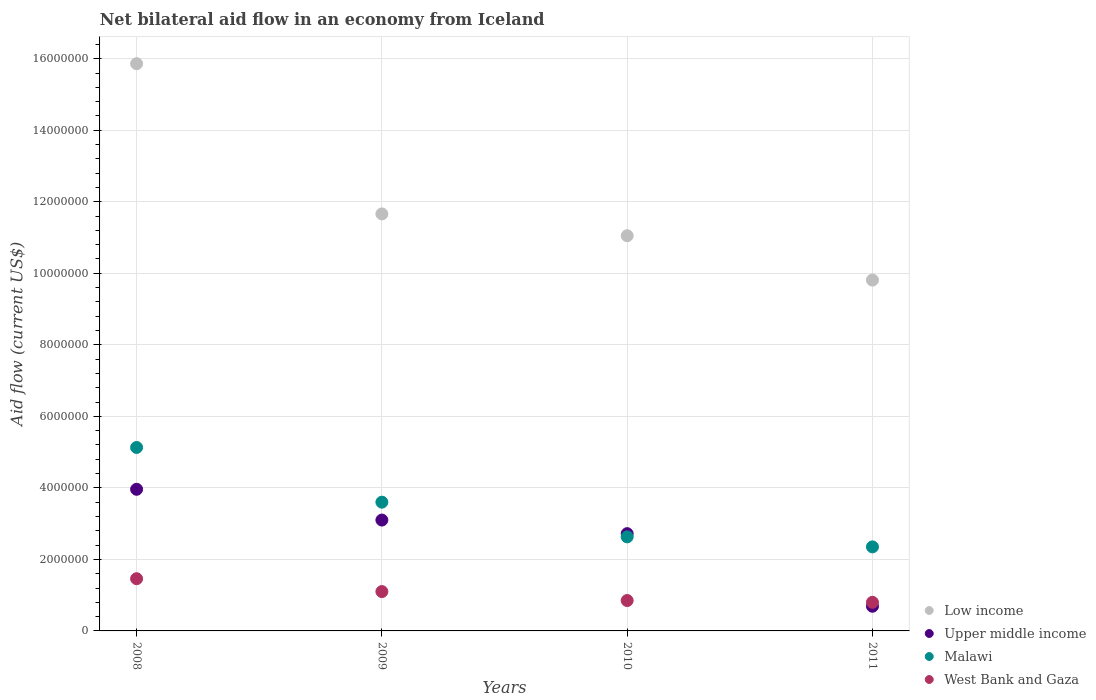How many different coloured dotlines are there?
Your answer should be very brief. 4. Is the number of dotlines equal to the number of legend labels?
Offer a terse response. Yes. What is the net bilateral aid flow in Upper middle income in 2010?
Give a very brief answer. 2.72e+06. Across all years, what is the maximum net bilateral aid flow in Malawi?
Offer a terse response. 5.13e+06. Across all years, what is the minimum net bilateral aid flow in Malawi?
Offer a terse response. 2.35e+06. What is the total net bilateral aid flow in West Bank and Gaza in the graph?
Offer a terse response. 4.21e+06. What is the difference between the net bilateral aid flow in Upper middle income in 2009 and that in 2011?
Make the answer very short. 2.41e+06. What is the difference between the net bilateral aid flow in Malawi in 2011 and the net bilateral aid flow in Upper middle income in 2008?
Provide a succinct answer. -1.61e+06. What is the average net bilateral aid flow in Upper middle income per year?
Keep it short and to the point. 2.62e+06. In the year 2008, what is the difference between the net bilateral aid flow in West Bank and Gaza and net bilateral aid flow in Upper middle income?
Offer a terse response. -2.50e+06. What is the ratio of the net bilateral aid flow in Low income in 2010 to that in 2011?
Provide a short and direct response. 1.13. What is the difference between the highest and the lowest net bilateral aid flow in Low income?
Your answer should be very brief. 6.05e+06. In how many years, is the net bilateral aid flow in West Bank and Gaza greater than the average net bilateral aid flow in West Bank and Gaza taken over all years?
Ensure brevity in your answer.  2. Is the sum of the net bilateral aid flow in West Bank and Gaza in 2008 and 2010 greater than the maximum net bilateral aid flow in Low income across all years?
Your answer should be compact. No. Is it the case that in every year, the sum of the net bilateral aid flow in Low income and net bilateral aid flow in West Bank and Gaza  is greater than the sum of net bilateral aid flow in Malawi and net bilateral aid flow in Upper middle income?
Offer a very short reply. Yes. Is the net bilateral aid flow in Malawi strictly greater than the net bilateral aid flow in Upper middle income over the years?
Keep it short and to the point. No. Is the net bilateral aid flow in Upper middle income strictly less than the net bilateral aid flow in Malawi over the years?
Offer a terse response. No. How many years are there in the graph?
Your answer should be compact. 4. Are the values on the major ticks of Y-axis written in scientific E-notation?
Your response must be concise. No. Does the graph contain any zero values?
Provide a short and direct response. No. Where does the legend appear in the graph?
Make the answer very short. Bottom right. What is the title of the graph?
Your answer should be compact. Net bilateral aid flow in an economy from Iceland. What is the label or title of the X-axis?
Ensure brevity in your answer.  Years. What is the Aid flow (current US$) of Low income in 2008?
Your answer should be compact. 1.59e+07. What is the Aid flow (current US$) in Upper middle income in 2008?
Provide a short and direct response. 3.96e+06. What is the Aid flow (current US$) of Malawi in 2008?
Your answer should be compact. 5.13e+06. What is the Aid flow (current US$) in West Bank and Gaza in 2008?
Your answer should be compact. 1.46e+06. What is the Aid flow (current US$) in Low income in 2009?
Your answer should be compact. 1.17e+07. What is the Aid flow (current US$) in Upper middle income in 2009?
Provide a succinct answer. 3.10e+06. What is the Aid flow (current US$) of Malawi in 2009?
Keep it short and to the point. 3.60e+06. What is the Aid flow (current US$) in West Bank and Gaza in 2009?
Provide a short and direct response. 1.10e+06. What is the Aid flow (current US$) of Low income in 2010?
Your response must be concise. 1.10e+07. What is the Aid flow (current US$) in Upper middle income in 2010?
Your response must be concise. 2.72e+06. What is the Aid flow (current US$) of Malawi in 2010?
Provide a succinct answer. 2.63e+06. What is the Aid flow (current US$) in West Bank and Gaza in 2010?
Give a very brief answer. 8.50e+05. What is the Aid flow (current US$) of Low income in 2011?
Ensure brevity in your answer.  9.81e+06. What is the Aid flow (current US$) of Upper middle income in 2011?
Your response must be concise. 6.90e+05. What is the Aid flow (current US$) in Malawi in 2011?
Keep it short and to the point. 2.35e+06. Across all years, what is the maximum Aid flow (current US$) in Low income?
Give a very brief answer. 1.59e+07. Across all years, what is the maximum Aid flow (current US$) in Upper middle income?
Offer a terse response. 3.96e+06. Across all years, what is the maximum Aid flow (current US$) in Malawi?
Your answer should be compact. 5.13e+06. Across all years, what is the maximum Aid flow (current US$) in West Bank and Gaza?
Offer a terse response. 1.46e+06. Across all years, what is the minimum Aid flow (current US$) in Low income?
Give a very brief answer. 9.81e+06. Across all years, what is the minimum Aid flow (current US$) in Upper middle income?
Ensure brevity in your answer.  6.90e+05. Across all years, what is the minimum Aid flow (current US$) in Malawi?
Give a very brief answer. 2.35e+06. Across all years, what is the minimum Aid flow (current US$) in West Bank and Gaza?
Give a very brief answer. 8.00e+05. What is the total Aid flow (current US$) of Low income in the graph?
Provide a succinct answer. 4.84e+07. What is the total Aid flow (current US$) of Upper middle income in the graph?
Your answer should be very brief. 1.05e+07. What is the total Aid flow (current US$) of Malawi in the graph?
Your answer should be very brief. 1.37e+07. What is the total Aid flow (current US$) of West Bank and Gaza in the graph?
Provide a succinct answer. 4.21e+06. What is the difference between the Aid flow (current US$) in Low income in 2008 and that in 2009?
Your answer should be compact. 4.20e+06. What is the difference between the Aid flow (current US$) in Upper middle income in 2008 and that in 2009?
Offer a very short reply. 8.60e+05. What is the difference between the Aid flow (current US$) of Malawi in 2008 and that in 2009?
Your answer should be very brief. 1.53e+06. What is the difference between the Aid flow (current US$) of Low income in 2008 and that in 2010?
Offer a terse response. 4.81e+06. What is the difference between the Aid flow (current US$) in Upper middle income in 2008 and that in 2010?
Provide a short and direct response. 1.24e+06. What is the difference between the Aid flow (current US$) in Malawi in 2008 and that in 2010?
Make the answer very short. 2.50e+06. What is the difference between the Aid flow (current US$) in Low income in 2008 and that in 2011?
Keep it short and to the point. 6.05e+06. What is the difference between the Aid flow (current US$) in Upper middle income in 2008 and that in 2011?
Give a very brief answer. 3.27e+06. What is the difference between the Aid flow (current US$) in Malawi in 2008 and that in 2011?
Provide a short and direct response. 2.78e+06. What is the difference between the Aid flow (current US$) of West Bank and Gaza in 2008 and that in 2011?
Provide a succinct answer. 6.60e+05. What is the difference between the Aid flow (current US$) of Low income in 2009 and that in 2010?
Your answer should be very brief. 6.10e+05. What is the difference between the Aid flow (current US$) in Upper middle income in 2009 and that in 2010?
Provide a succinct answer. 3.80e+05. What is the difference between the Aid flow (current US$) in Malawi in 2009 and that in 2010?
Offer a terse response. 9.70e+05. What is the difference between the Aid flow (current US$) of West Bank and Gaza in 2009 and that in 2010?
Provide a succinct answer. 2.50e+05. What is the difference between the Aid flow (current US$) in Low income in 2009 and that in 2011?
Keep it short and to the point. 1.85e+06. What is the difference between the Aid flow (current US$) of Upper middle income in 2009 and that in 2011?
Offer a very short reply. 2.41e+06. What is the difference between the Aid flow (current US$) of Malawi in 2009 and that in 2011?
Make the answer very short. 1.25e+06. What is the difference between the Aid flow (current US$) of West Bank and Gaza in 2009 and that in 2011?
Make the answer very short. 3.00e+05. What is the difference between the Aid flow (current US$) of Low income in 2010 and that in 2011?
Give a very brief answer. 1.24e+06. What is the difference between the Aid flow (current US$) of Upper middle income in 2010 and that in 2011?
Offer a very short reply. 2.03e+06. What is the difference between the Aid flow (current US$) in Low income in 2008 and the Aid flow (current US$) in Upper middle income in 2009?
Keep it short and to the point. 1.28e+07. What is the difference between the Aid flow (current US$) in Low income in 2008 and the Aid flow (current US$) in Malawi in 2009?
Your answer should be very brief. 1.23e+07. What is the difference between the Aid flow (current US$) of Low income in 2008 and the Aid flow (current US$) of West Bank and Gaza in 2009?
Keep it short and to the point. 1.48e+07. What is the difference between the Aid flow (current US$) of Upper middle income in 2008 and the Aid flow (current US$) of Malawi in 2009?
Offer a terse response. 3.60e+05. What is the difference between the Aid flow (current US$) in Upper middle income in 2008 and the Aid flow (current US$) in West Bank and Gaza in 2009?
Ensure brevity in your answer.  2.86e+06. What is the difference between the Aid flow (current US$) in Malawi in 2008 and the Aid flow (current US$) in West Bank and Gaza in 2009?
Make the answer very short. 4.03e+06. What is the difference between the Aid flow (current US$) of Low income in 2008 and the Aid flow (current US$) of Upper middle income in 2010?
Offer a terse response. 1.31e+07. What is the difference between the Aid flow (current US$) in Low income in 2008 and the Aid flow (current US$) in Malawi in 2010?
Provide a succinct answer. 1.32e+07. What is the difference between the Aid flow (current US$) in Low income in 2008 and the Aid flow (current US$) in West Bank and Gaza in 2010?
Offer a very short reply. 1.50e+07. What is the difference between the Aid flow (current US$) of Upper middle income in 2008 and the Aid flow (current US$) of Malawi in 2010?
Your answer should be compact. 1.33e+06. What is the difference between the Aid flow (current US$) in Upper middle income in 2008 and the Aid flow (current US$) in West Bank and Gaza in 2010?
Your response must be concise. 3.11e+06. What is the difference between the Aid flow (current US$) in Malawi in 2008 and the Aid flow (current US$) in West Bank and Gaza in 2010?
Give a very brief answer. 4.28e+06. What is the difference between the Aid flow (current US$) of Low income in 2008 and the Aid flow (current US$) of Upper middle income in 2011?
Provide a short and direct response. 1.52e+07. What is the difference between the Aid flow (current US$) of Low income in 2008 and the Aid flow (current US$) of Malawi in 2011?
Your answer should be very brief. 1.35e+07. What is the difference between the Aid flow (current US$) in Low income in 2008 and the Aid flow (current US$) in West Bank and Gaza in 2011?
Offer a very short reply. 1.51e+07. What is the difference between the Aid flow (current US$) of Upper middle income in 2008 and the Aid flow (current US$) of Malawi in 2011?
Provide a short and direct response. 1.61e+06. What is the difference between the Aid flow (current US$) in Upper middle income in 2008 and the Aid flow (current US$) in West Bank and Gaza in 2011?
Your answer should be very brief. 3.16e+06. What is the difference between the Aid flow (current US$) in Malawi in 2008 and the Aid flow (current US$) in West Bank and Gaza in 2011?
Your response must be concise. 4.33e+06. What is the difference between the Aid flow (current US$) in Low income in 2009 and the Aid flow (current US$) in Upper middle income in 2010?
Offer a terse response. 8.94e+06. What is the difference between the Aid flow (current US$) in Low income in 2009 and the Aid flow (current US$) in Malawi in 2010?
Keep it short and to the point. 9.03e+06. What is the difference between the Aid flow (current US$) of Low income in 2009 and the Aid flow (current US$) of West Bank and Gaza in 2010?
Keep it short and to the point. 1.08e+07. What is the difference between the Aid flow (current US$) of Upper middle income in 2009 and the Aid flow (current US$) of West Bank and Gaza in 2010?
Keep it short and to the point. 2.25e+06. What is the difference between the Aid flow (current US$) in Malawi in 2009 and the Aid flow (current US$) in West Bank and Gaza in 2010?
Provide a short and direct response. 2.75e+06. What is the difference between the Aid flow (current US$) of Low income in 2009 and the Aid flow (current US$) of Upper middle income in 2011?
Provide a short and direct response. 1.10e+07. What is the difference between the Aid flow (current US$) of Low income in 2009 and the Aid flow (current US$) of Malawi in 2011?
Your answer should be compact. 9.31e+06. What is the difference between the Aid flow (current US$) in Low income in 2009 and the Aid flow (current US$) in West Bank and Gaza in 2011?
Your response must be concise. 1.09e+07. What is the difference between the Aid flow (current US$) in Upper middle income in 2009 and the Aid flow (current US$) in Malawi in 2011?
Provide a succinct answer. 7.50e+05. What is the difference between the Aid flow (current US$) in Upper middle income in 2009 and the Aid flow (current US$) in West Bank and Gaza in 2011?
Give a very brief answer. 2.30e+06. What is the difference between the Aid flow (current US$) of Malawi in 2009 and the Aid flow (current US$) of West Bank and Gaza in 2011?
Offer a terse response. 2.80e+06. What is the difference between the Aid flow (current US$) of Low income in 2010 and the Aid flow (current US$) of Upper middle income in 2011?
Your answer should be compact. 1.04e+07. What is the difference between the Aid flow (current US$) in Low income in 2010 and the Aid flow (current US$) in Malawi in 2011?
Your answer should be very brief. 8.70e+06. What is the difference between the Aid flow (current US$) in Low income in 2010 and the Aid flow (current US$) in West Bank and Gaza in 2011?
Give a very brief answer. 1.02e+07. What is the difference between the Aid flow (current US$) of Upper middle income in 2010 and the Aid flow (current US$) of West Bank and Gaza in 2011?
Give a very brief answer. 1.92e+06. What is the difference between the Aid flow (current US$) of Malawi in 2010 and the Aid flow (current US$) of West Bank and Gaza in 2011?
Provide a succinct answer. 1.83e+06. What is the average Aid flow (current US$) of Low income per year?
Keep it short and to the point. 1.21e+07. What is the average Aid flow (current US$) in Upper middle income per year?
Offer a very short reply. 2.62e+06. What is the average Aid flow (current US$) in Malawi per year?
Your answer should be very brief. 3.43e+06. What is the average Aid flow (current US$) in West Bank and Gaza per year?
Your answer should be compact. 1.05e+06. In the year 2008, what is the difference between the Aid flow (current US$) of Low income and Aid flow (current US$) of Upper middle income?
Your answer should be compact. 1.19e+07. In the year 2008, what is the difference between the Aid flow (current US$) in Low income and Aid flow (current US$) in Malawi?
Keep it short and to the point. 1.07e+07. In the year 2008, what is the difference between the Aid flow (current US$) of Low income and Aid flow (current US$) of West Bank and Gaza?
Your response must be concise. 1.44e+07. In the year 2008, what is the difference between the Aid flow (current US$) of Upper middle income and Aid flow (current US$) of Malawi?
Your answer should be compact. -1.17e+06. In the year 2008, what is the difference between the Aid flow (current US$) in Upper middle income and Aid flow (current US$) in West Bank and Gaza?
Give a very brief answer. 2.50e+06. In the year 2008, what is the difference between the Aid flow (current US$) of Malawi and Aid flow (current US$) of West Bank and Gaza?
Provide a short and direct response. 3.67e+06. In the year 2009, what is the difference between the Aid flow (current US$) in Low income and Aid flow (current US$) in Upper middle income?
Give a very brief answer. 8.56e+06. In the year 2009, what is the difference between the Aid flow (current US$) of Low income and Aid flow (current US$) of Malawi?
Give a very brief answer. 8.06e+06. In the year 2009, what is the difference between the Aid flow (current US$) of Low income and Aid flow (current US$) of West Bank and Gaza?
Keep it short and to the point. 1.06e+07. In the year 2009, what is the difference between the Aid flow (current US$) in Upper middle income and Aid flow (current US$) in Malawi?
Your answer should be compact. -5.00e+05. In the year 2009, what is the difference between the Aid flow (current US$) in Malawi and Aid flow (current US$) in West Bank and Gaza?
Provide a short and direct response. 2.50e+06. In the year 2010, what is the difference between the Aid flow (current US$) of Low income and Aid flow (current US$) of Upper middle income?
Offer a very short reply. 8.33e+06. In the year 2010, what is the difference between the Aid flow (current US$) of Low income and Aid flow (current US$) of Malawi?
Offer a very short reply. 8.42e+06. In the year 2010, what is the difference between the Aid flow (current US$) of Low income and Aid flow (current US$) of West Bank and Gaza?
Make the answer very short. 1.02e+07. In the year 2010, what is the difference between the Aid flow (current US$) of Upper middle income and Aid flow (current US$) of West Bank and Gaza?
Ensure brevity in your answer.  1.87e+06. In the year 2010, what is the difference between the Aid flow (current US$) of Malawi and Aid flow (current US$) of West Bank and Gaza?
Give a very brief answer. 1.78e+06. In the year 2011, what is the difference between the Aid flow (current US$) of Low income and Aid flow (current US$) of Upper middle income?
Make the answer very short. 9.12e+06. In the year 2011, what is the difference between the Aid flow (current US$) of Low income and Aid flow (current US$) of Malawi?
Ensure brevity in your answer.  7.46e+06. In the year 2011, what is the difference between the Aid flow (current US$) in Low income and Aid flow (current US$) in West Bank and Gaza?
Provide a short and direct response. 9.01e+06. In the year 2011, what is the difference between the Aid flow (current US$) in Upper middle income and Aid flow (current US$) in Malawi?
Provide a short and direct response. -1.66e+06. In the year 2011, what is the difference between the Aid flow (current US$) in Upper middle income and Aid flow (current US$) in West Bank and Gaza?
Give a very brief answer. -1.10e+05. In the year 2011, what is the difference between the Aid flow (current US$) in Malawi and Aid flow (current US$) in West Bank and Gaza?
Your answer should be compact. 1.55e+06. What is the ratio of the Aid flow (current US$) of Low income in 2008 to that in 2009?
Keep it short and to the point. 1.36. What is the ratio of the Aid flow (current US$) in Upper middle income in 2008 to that in 2009?
Your response must be concise. 1.28. What is the ratio of the Aid flow (current US$) of Malawi in 2008 to that in 2009?
Your response must be concise. 1.43. What is the ratio of the Aid flow (current US$) in West Bank and Gaza in 2008 to that in 2009?
Your answer should be compact. 1.33. What is the ratio of the Aid flow (current US$) in Low income in 2008 to that in 2010?
Provide a succinct answer. 1.44. What is the ratio of the Aid flow (current US$) of Upper middle income in 2008 to that in 2010?
Your answer should be very brief. 1.46. What is the ratio of the Aid flow (current US$) of Malawi in 2008 to that in 2010?
Provide a short and direct response. 1.95. What is the ratio of the Aid flow (current US$) in West Bank and Gaza in 2008 to that in 2010?
Give a very brief answer. 1.72. What is the ratio of the Aid flow (current US$) in Low income in 2008 to that in 2011?
Offer a very short reply. 1.62. What is the ratio of the Aid flow (current US$) in Upper middle income in 2008 to that in 2011?
Ensure brevity in your answer.  5.74. What is the ratio of the Aid flow (current US$) in Malawi in 2008 to that in 2011?
Your response must be concise. 2.18. What is the ratio of the Aid flow (current US$) in West Bank and Gaza in 2008 to that in 2011?
Provide a succinct answer. 1.82. What is the ratio of the Aid flow (current US$) of Low income in 2009 to that in 2010?
Keep it short and to the point. 1.06. What is the ratio of the Aid flow (current US$) of Upper middle income in 2009 to that in 2010?
Your answer should be compact. 1.14. What is the ratio of the Aid flow (current US$) in Malawi in 2009 to that in 2010?
Make the answer very short. 1.37. What is the ratio of the Aid flow (current US$) of West Bank and Gaza in 2009 to that in 2010?
Give a very brief answer. 1.29. What is the ratio of the Aid flow (current US$) in Low income in 2009 to that in 2011?
Give a very brief answer. 1.19. What is the ratio of the Aid flow (current US$) of Upper middle income in 2009 to that in 2011?
Provide a short and direct response. 4.49. What is the ratio of the Aid flow (current US$) of Malawi in 2009 to that in 2011?
Provide a succinct answer. 1.53. What is the ratio of the Aid flow (current US$) of West Bank and Gaza in 2009 to that in 2011?
Provide a short and direct response. 1.38. What is the ratio of the Aid flow (current US$) of Low income in 2010 to that in 2011?
Provide a short and direct response. 1.13. What is the ratio of the Aid flow (current US$) of Upper middle income in 2010 to that in 2011?
Keep it short and to the point. 3.94. What is the ratio of the Aid flow (current US$) in Malawi in 2010 to that in 2011?
Your response must be concise. 1.12. What is the ratio of the Aid flow (current US$) in West Bank and Gaza in 2010 to that in 2011?
Provide a short and direct response. 1.06. What is the difference between the highest and the second highest Aid flow (current US$) of Low income?
Your response must be concise. 4.20e+06. What is the difference between the highest and the second highest Aid flow (current US$) in Upper middle income?
Provide a short and direct response. 8.60e+05. What is the difference between the highest and the second highest Aid flow (current US$) of Malawi?
Provide a succinct answer. 1.53e+06. What is the difference between the highest and the second highest Aid flow (current US$) in West Bank and Gaza?
Offer a terse response. 3.60e+05. What is the difference between the highest and the lowest Aid flow (current US$) of Low income?
Your answer should be compact. 6.05e+06. What is the difference between the highest and the lowest Aid flow (current US$) in Upper middle income?
Provide a succinct answer. 3.27e+06. What is the difference between the highest and the lowest Aid flow (current US$) of Malawi?
Make the answer very short. 2.78e+06. What is the difference between the highest and the lowest Aid flow (current US$) of West Bank and Gaza?
Offer a terse response. 6.60e+05. 